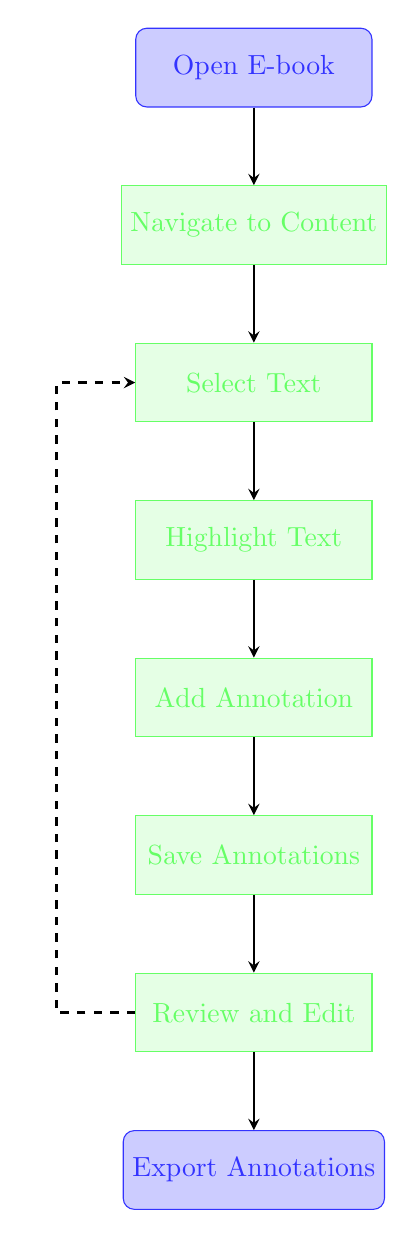What is the first step listed in the diagram? The diagram begins with the first node labeled "Open E-book," which indicates the initial action.
Answer: Open E-book How many total steps are represented in the diagram? By counting the nodes, there are eight steps depicted in the flow chart from "Open E-book" to "Export Annotations."
Answer: Eight What step comes after "Highlight Text"? The flow chart shows that the step immediately following "Highlight Text" is "Add Annotation."
Answer: Add Annotation What is the last step in the flow chart? The final node in the diagram indicates the last action to be taken, which is "Export Annotations."
Answer: Export Annotations Explain the dashed arrow's significance. The dashed arrow connects "Review and Edit" back to "Select Text," indicating that after reviewing annotations, one may need to go back and select text again for further annotation.
Answer: It shows a feedback loop What step follows "Save Annotations"? According to the diagram, the step that comes after "Save Annotations" is "Review and Edit."
Answer: Review and Edit Which action happens right before "Export Annotations"? The action that occurs directly prior to "Export Annotations" is "Review and Edit."
Answer: Review and Edit What type of arrow connects the steps in the diagram? The arrows used in the flow chart are thick, directed arrows that illustrate the flow from one step to another, specifically noted as "->" in the diagram.
Answer: Thick arrows What does the flow of arrows signify in this diagram? The arrows indicate the progression of steps to take when annotating and highlighting information in e-books, guiding the user through the process sequentially.
Answer: Sequential process 